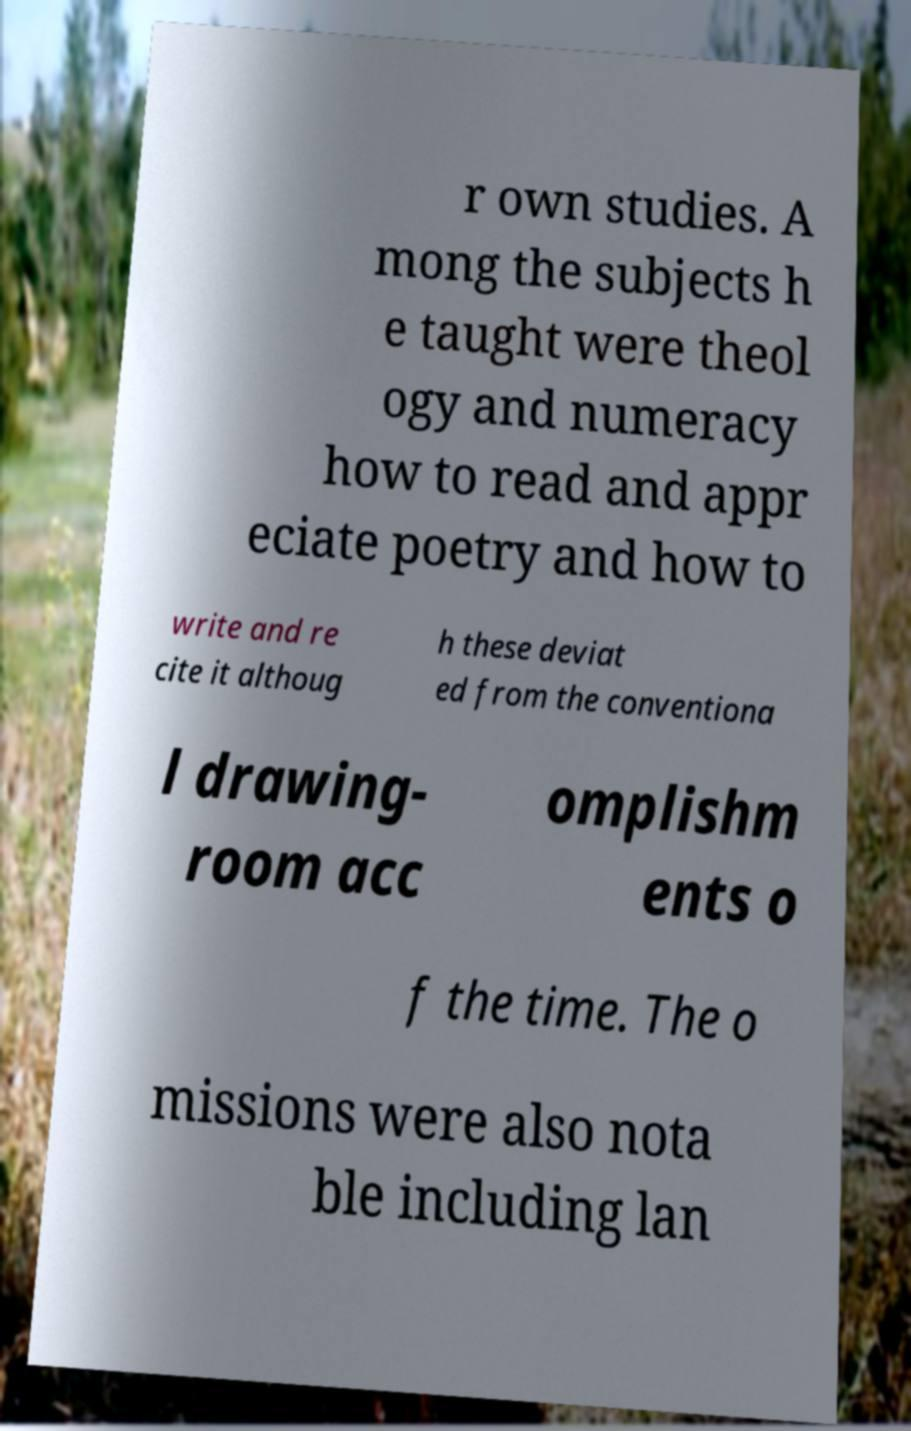For documentation purposes, I need the text within this image transcribed. Could you provide that? r own studies. A mong the subjects h e taught were theol ogy and numeracy how to read and appr eciate poetry and how to write and re cite it althoug h these deviat ed from the conventiona l drawing- room acc omplishm ents o f the time. The o missions were also nota ble including lan 